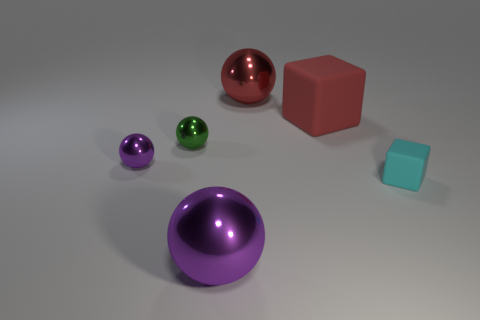What number of yellow objects are either rubber blocks or small metallic spheres?
Give a very brief answer. 0. Do the metal thing that is in front of the tiny cyan rubber cube and the large red thing in front of the big red metal object have the same shape?
Provide a succinct answer. No. There is a tiny matte cube; is it the same color as the large metal ball that is in front of the big red ball?
Give a very brief answer. No. There is a shiny sphere that is in front of the tiny matte block; is it the same color as the tiny rubber object?
Your response must be concise. No. What number of objects are big green things or big metallic spheres that are behind the big matte block?
Offer a terse response. 1. What is the thing that is on the right side of the big red ball and in front of the big matte block made of?
Make the answer very short. Rubber. There is a big thing in front of the small green metal ball; what is its material?
Offer a very short reply. Metal. What is the color of the tiny object that is made of the same material as the tiny green sphere?
Give a very brief answer. Purple. There is a tiny green object; is its shape the same as the big metallic thing behind the large red block?
Make the answer very short. Yes. Are there any small purple things in front of the small purple thing?
Your answer should be very brief. No. 